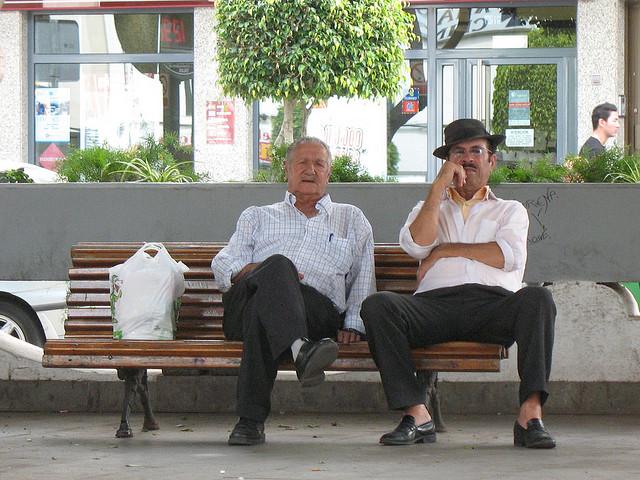Is the bench on pavement?
Answer briefly. Yes. What are the men sitting on?
Answer briefly. Bench. Do the men look serious?
Write a very short answer. Yes. 